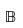<formula> <loc_0><loc_0><loc_500><loc_500>\mathbb { B }</formula> 